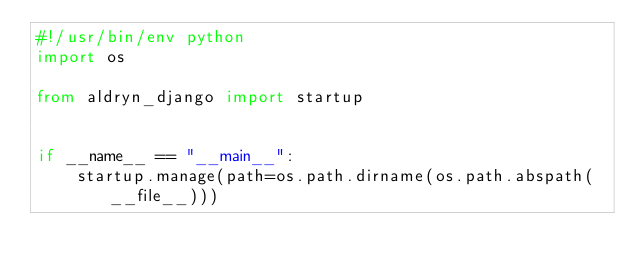Convert code to text. <code><loc_0><loc_0><loc_500><loc_500><_Python_>#!/usr/bin/env python
import os

from aldryn_django import startup


if __name__ == "__main__":
    startup.manage(path=os.path.dirname(os.path.abspath(__file__)))
</code> 